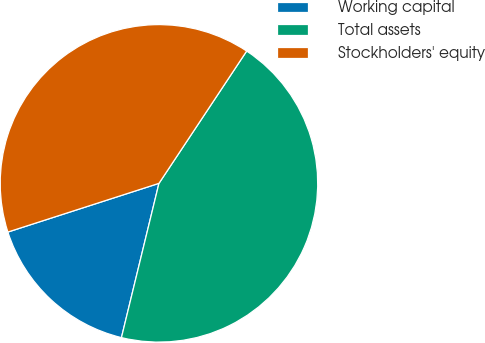Convert chart to OTSL. <chart><loc_0><loc_0><loc_500><loc_500><pie_chart><fcel>Working capital<fcel>Total assets<fcel>Stockholders' equity<nl><fcel>16.24%<fcel>44.48%<fcel>39.28%<nl></chart> 